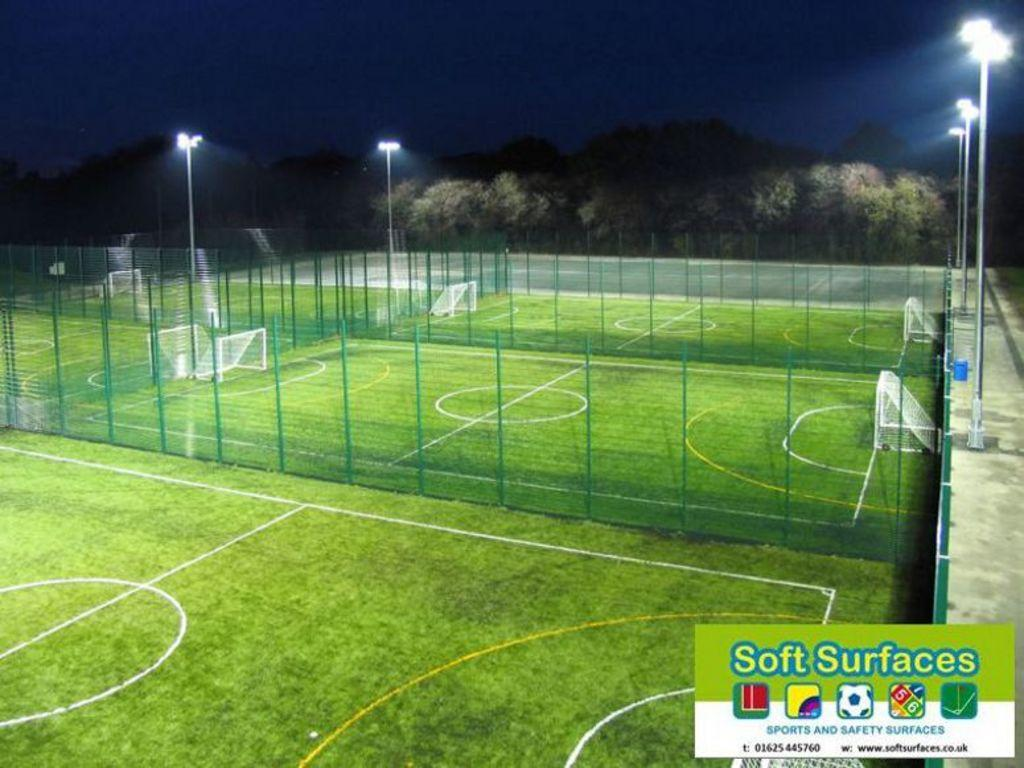<image>
Relay a brief, clear account of the picture shown. a field photo that says 'soft surfaces' at the bottom right 